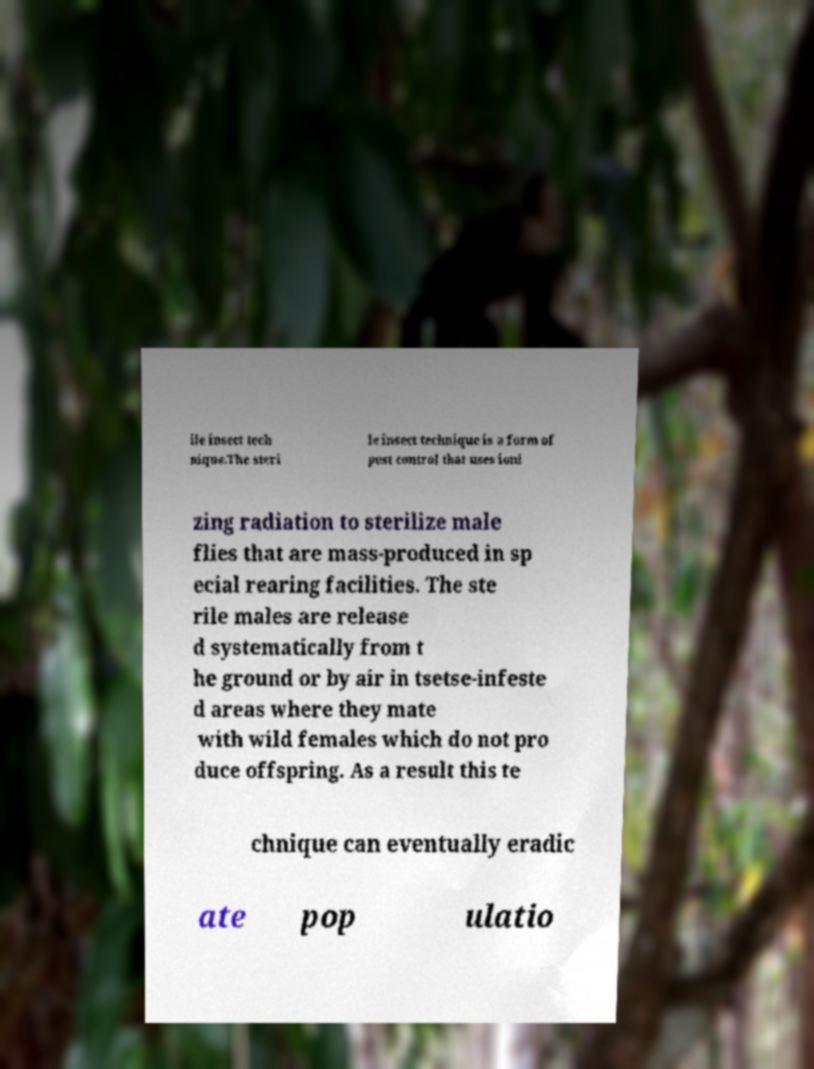Please read and relay the text visible in this image. What does it say? ile insect tech nique.The steri le insect technique is a form of pest control that uses ioni zing radiation to sterilize male flies that are mass-produced in sp ecial rearing facilities. The ste rile males are release d systematically from t he ground or by air in tsetse-infeste d areas where they mate with wild females which do not pro duce offspring. As a result this te chnique can eventually eradic ate pop ulatio 